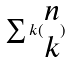<formula> <loc_0><loc_0><loc_500><loc_500>\sum k ( \begin{matrix} n \\ k \end{matrix} )</formula> 